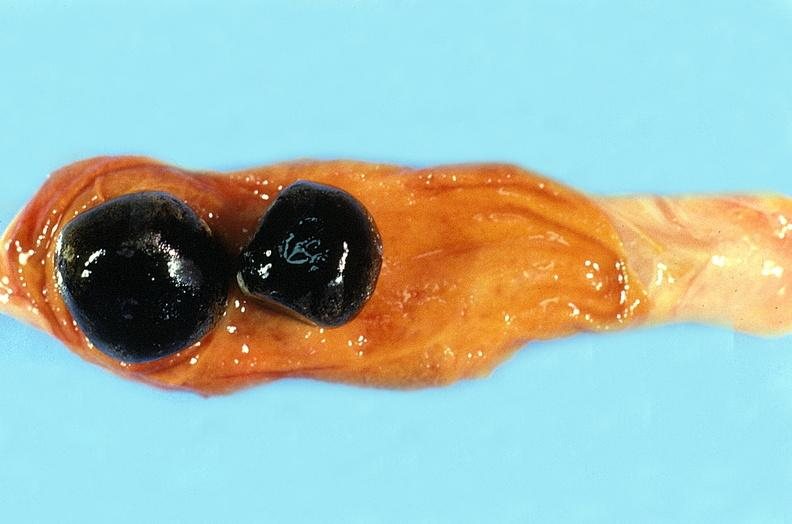what does this image show?
Answer the question using a single word or phrase. Ureter 